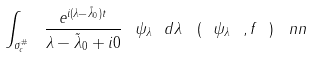Convert formula to latex. <formula><loc_0><loc_0><loc_500><loc_500>\int _ { \sigma _ { c } ^ { \# } } \ \frac { e ^ { i ( \lambda - \tilde { \lambda } _ { 0 } ) t } } { \lambda - \tilde { \lambda } _ { 0 } + i 0 } \ \psi _ { \lambda } \ d \lambda \ \left ( \ \psi _ { \lambda } \ , f \ \right ) \ n n</formula> 